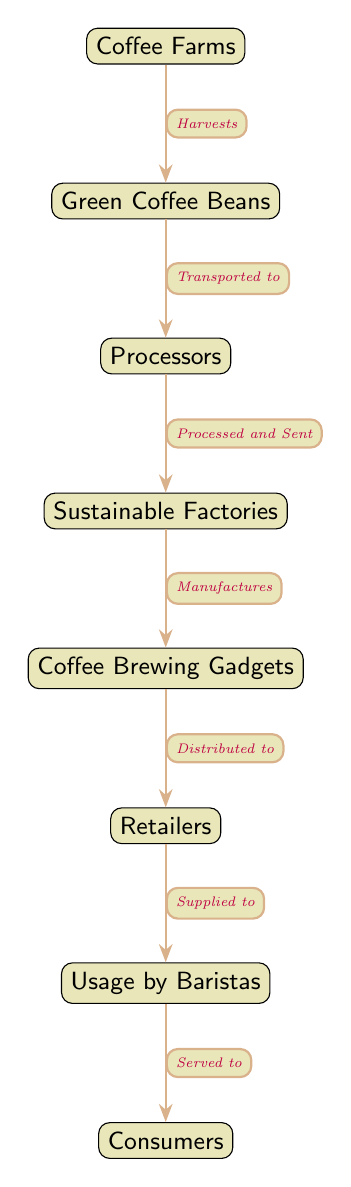What's the first node in the diagram? The first node in the diagram is "Coffee Farms." It is positioned at the top and serves as the starting point of the food chain.
Answer: Coffee Farms How many nodes are present in the diagram? The diagram contains a total of 8 nodes. Counting each distinct segment from "Coffee Farms" down to "Consumers" gives us this total.
Answer: 8 What is the relationship between "Processors" and "Sustainable Factories"? The relationship is that "Processors" are "Processed and Sent" to "Sustainable Factories." This arrow indicates the flow from one node to the next.
Answer: Processed and Sent Which node comes after "Gadgets" in the chain? The node that comes after "Gadgets" is "Retailers." It follows directly in the sequence of production and distribution.
Answer: Retailers What action occurs when "Coffee Farms" sends output to the next node? The action is called "Harvests." This describes the harvesting process of coffee beans from farms to produce the raw material.
Answer: Harvests How does "Consumers" receive the coffee? "Consumers" receive coffee that has been "Served to" them by "Baristas." This indicates the final step of the consumption process of coffee.
Answer: Served to What is produced at "Sustainable Factories"? The production at "Sustainable Factories" involves "Coffee Brewing Gadgets." This node illustrates what is manufactured at that stage.
Answer: Coffee Brewing Gadgets Which nodes are connected by the edge labeled "Transported to"? The nodes connected by this edge are "Green Coffee Beans" and "Processors." This step details the transportation flow in the chain.
Answer: Green Coffee Beans and Processors What is the last node in the food chain? The last node in the food chain is "Consumers." It indicates the endpoint where the final product reaches the end-user.
Answer: Consumers 